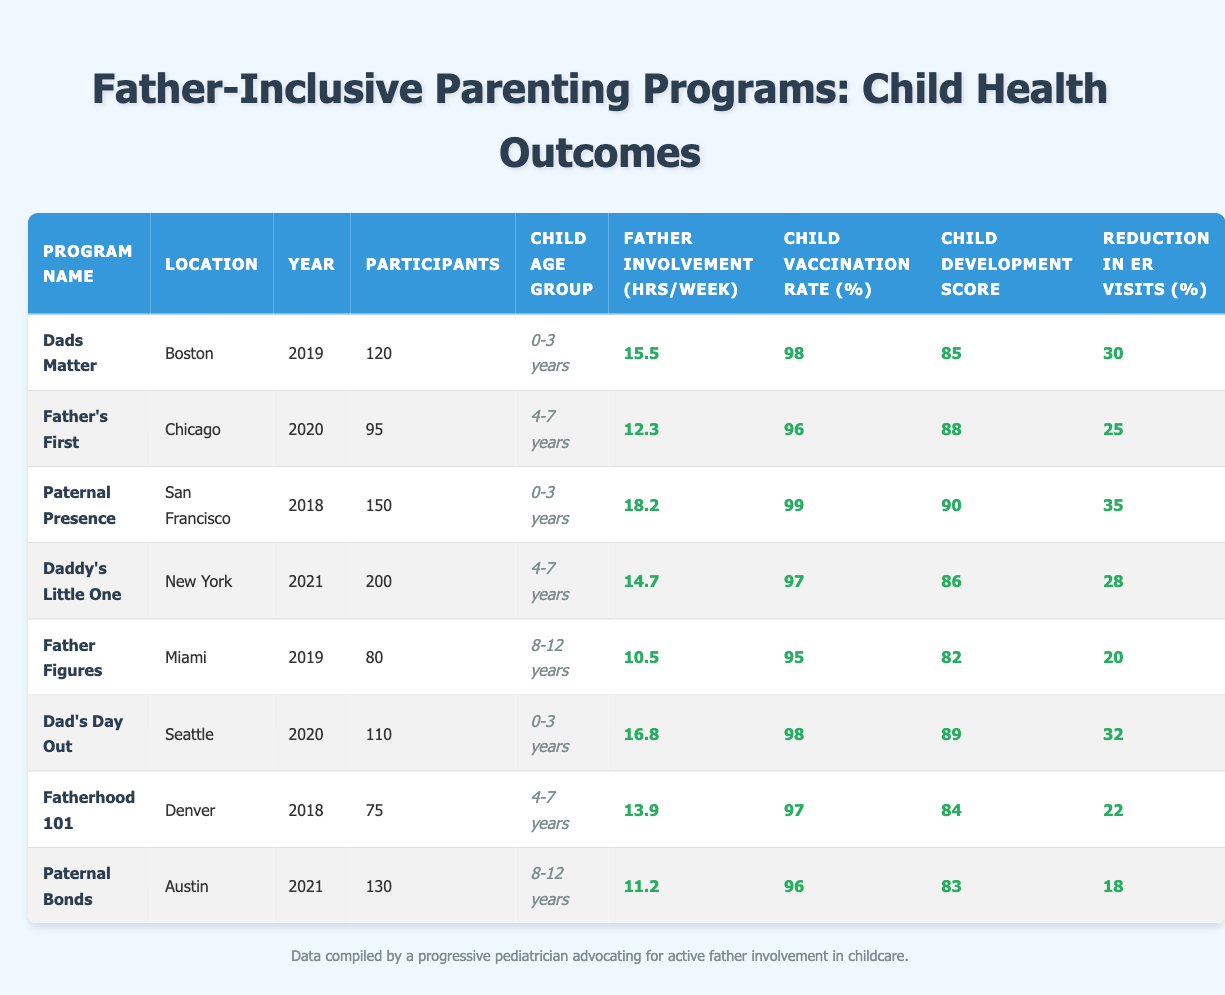What is the highest child vaccination rate recorded in the table? The highest child vaccination rate can be found by scanning the "Child Vaccination Rate (%)" column. The maximum value is 99%, which is associated with the program "Paternal Presence" in San Francisco.
Answer: 99% What is the average reduction in ER visits for programs targeting children aged 0-3 years? For the age group 0-3 years, the applicable programs are "Dads Matter," "Paternal Presence," and "Dad's Day Out." Their reduction rates are 30%, 35%, and 32% respectively. The average is calculated as (30 + 35 + 32) / 3 = 97 / 3 = 32.33.
Answer: 32.33% How many participants were involved in the "Daddy's Little One" program? Looking at the "Participants" column, the program "Daddy's Little One" shows a count of 200 participants.
Answer: 200 Is there a program with more than 100 participants that has a child development score above 85? Scanning through the table, "Paternal Presence" with 150 participants and a score of 90, "Daddy's Little One" with 200 participants and a score of 86, and "Dad's Day Out" with 110 participants and a score of 89 all meet these criteria. Therefore, the answer is YES.
Answer: Yes What is the lowest father involvement hours per week recorded among programs for 8-12 years? In the "Father Involvement (hrs/week)" column for programs targeting 8-12 years, "Father Figures" shows 10.5 hours, while "Paternal Bonds" shows 11.2 hours. Thus, the lowest is 10.5 hours.
Answer: 10.5 What is the difference in child development scores between the two programs targeting 4-7 years? For the two programs "Father's First" and "Fatherhood 101," the scores are 88 and 84 respectively. The difference is calculated as 88 - 84 = 4.
Answer: 4 Which program had the highest number of participants and what was the reduction in ER visits associated with it? The program "Daddy's Little One" has the highest number of participants at 200, with a reduction in ER visits of 28%.
Answer: 28% How many father involvement hours per week are associated with the program that had the lowest child vaccination rate? The program "Father Figures" has the lowest child vaccination rate of 95%, which corresponds to 10.5 hours of father involvement per week.
Answer: 10.5 What were the child development scores for the programs running in Miami? In Miami, the only program listed is "Father Figures," which has a child development score of 82.
Answer: 82 What is the relationship between the father involvement hours and child development scores in programs targeting the same age group? Specifically for age groups, data in the table indicates that as father involvement hours increase, child development scores generally improve. For instance, "Dads Matter" has 15.5 hours and a score of 85, while "Paternal Presence" with 18.2 hours has a score of 90. This suggests a positive correlation between the two.
Answer: Positive correlation 